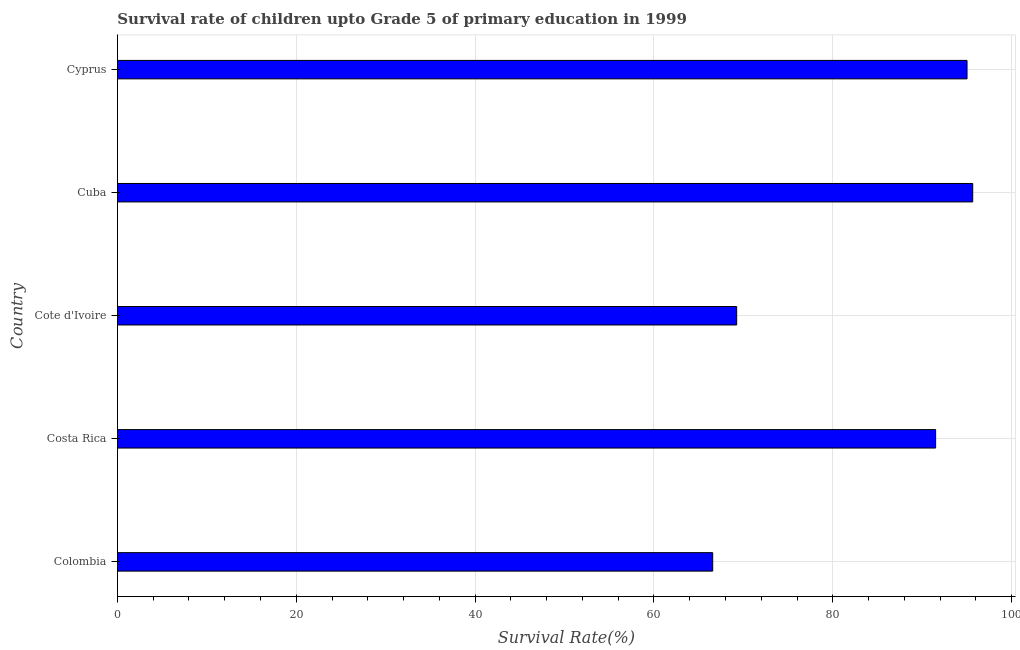What is the title of the graph?
Keep it short and to the point. Survival rate of children upto Grade 5 of primary education in 1999 . What is the label or title of the X-axis?
Provide a succinct answer. Survival Rate(%). What is the survival rate in Colombia?
Provide a succinct answer. 66.57. Across all countries, what is the maximum survival rate?
Provide a short and direct response. 95.65. Across all countries, what is the minimum survival rate?
Ensure brevity in your answer.  66.57. In which country was the survival rate maximum?
Give a very brief answer. Cuba. In which country was the survival rate minimum?
Provide a succinct answer. Colombia. What is the sum of the survival rate?
Make the answer very short. 417.97. What is the difference between the survival rate in Costa Rica and Cote d'Ivoire?
Give a very brief answer. 22.25. What is the average survival rate per country?
Ensure brevity in your answer.  83.59. What is the median survival rate?
Make the answer very short. 91.5. What is the difference between the highest and the second highest survival rate?
Provide a short and direct response. 0.64. What is the difference between the highest and the lowest survival rate?
Your response must be concise. 29.08. How many countries are there in the graph?
Offer a very short reply. 5. What is the Survival Rate(%) of Colombia?
Make the answer very short. 66.57. What is the Survival Rate(%) of Costa Rica?
Your response must be concise. 91.5. What is the Survival Rate(%) in Cote d'Ivoire?
Give a very brief answer. 69.25. What is the Survival Rate(%) in Cuba?
Offer a terse response. 95.65. What is the Survival Rate(%) in Cyprus?
Provide a short and direct response. 95.01. What is the difference between the Survival Rate(%) in Colombia and Costa Rica?
Your answer should be very brief. -24.93. What is the difference between the Survival Rate(%) in Colombia and Cote d'Ivoire?
Provide a short and direct response. -2.68. What is the difference between the Survival Rate(%) in Colombia and Cuba?
Your answer should be compact. -29.08. What is the difference between the Survival Rate(%) in Colombia and Cyprus?
Offer a very short reply. -28.44. What is the difference between the Survival Rate(%) in Costa Rica and Cote d'Ivoire?
Offer a terse response. 22.25. What is the difference between the Survival Rate(%) in Costa Rica and Cuba?
Offer a terse response. -4.15. What is the difference between the Survival Rate(%) in Costa Rica and Cyprus?
Ensure brevity in your answer.  -3.51. What is the difference between the Survival Rate(%) in Cote d'Ivoire and Cuba?
Ensure brevity in your answer.  -26.4. What is the difference between the Survival Rate(%) in Cote d'Ivoire and Cyprus?
Offer a very short reply. -25.76. What is the difference between the Survival Rate(%) in Cuba and Cyprus?
Offer a terse response. 0.64. What is the ratio of the Survival Rate(%) in Colombia to that in Costa Rica?
Give a very brief answer. 0.73. What is the ratio of the Survival Rate(%) in Colombia to that in Cuba?
Make the answer very short. 0.7. What is the ratio of the Survival Rate(%) in Colombia to that in Cyprus?
Keep it short and to the point. 0.7. What is the ratio of the Survival Rate(%) in Costa Rica to that in Cote d'Ivoire?
Your answer should be compact. 1.32. What is the ratio of the Survival Rate(%) in Cote d'Ivoire to that in Cuba?
Offer a very short reply. 0.72. What is the ratio of the Survival Rate(%) in Cote d'Ivoire to that in Cyprus?
Make the answer very short. 0.73. 